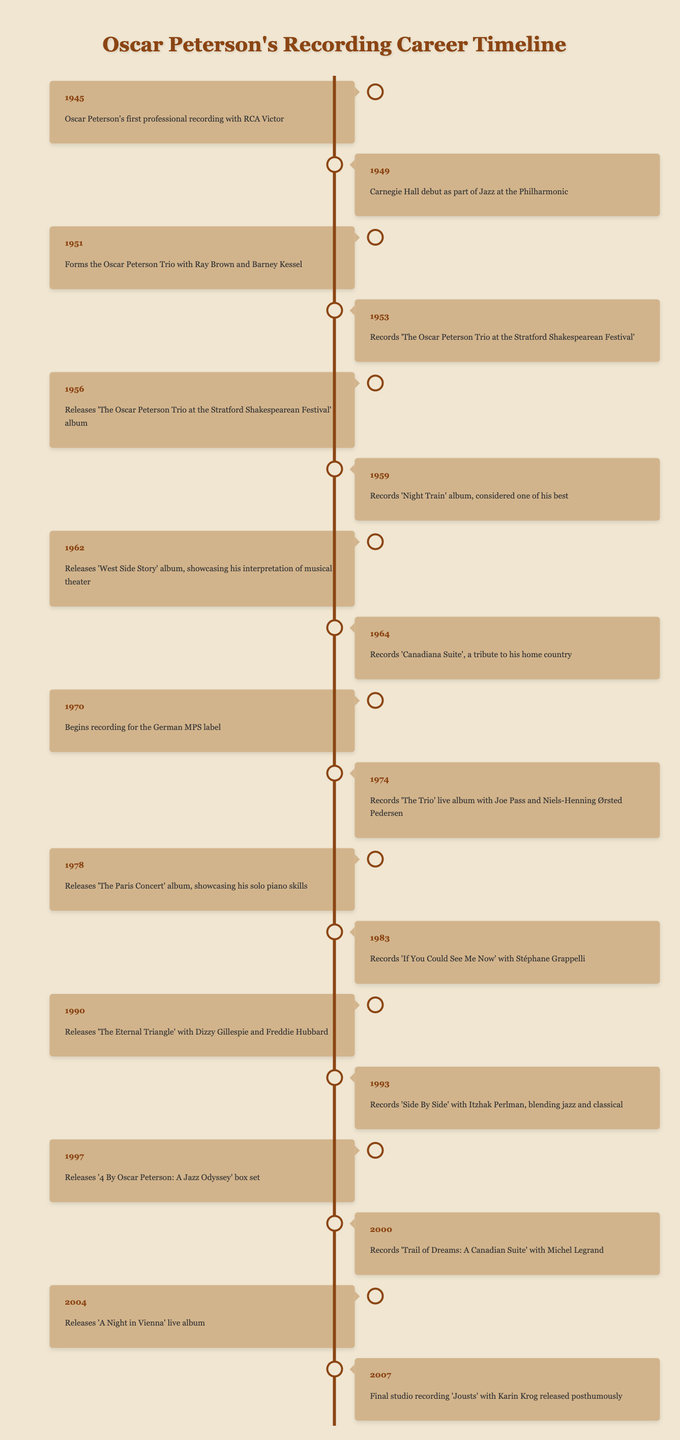What year did Oscar Peterson release 'Night Train'? The table shows that 'Night Train' was recorded in the year 1959.
Answer: 1959 What event took place in 1974? The 1974 entry in the table indicates that he recorded 'The Trio' live album with Joe Pass and Niels-Henning Ørsted Pedersen.
Answer: Records 'The Trio' live album with Joe Pass and Niels-Henning Ørsted Pedersen Did Oscar Peterson form the Oscar Peterson Trio before or after 1950? The table states he formed the Oscar Peterson Trio in 1951, which is after 1950.
Answer: After How many albums did Oscar Peterson release from 1950 to 1970? From 1951 to 1970, the table lists five albums: 'The Oscar Peterson Trio at the Stratford Shakespearean Festival' (1956), 'Night Train' (1959), 'West Side Story' (1962), 'Canadiana Suite' (1964), and 'Begins recording for the German MPS label' (1970). Thus, he released five albums in total.
Answer: 5 What is the first event listed in the timeline? The first event in the timeline is Oscar Peterson's first professional recording with RCA Victor, which occurred in 1945.
Answer: Oscar Peterson's first professional recording with RCA Victor Which albums showcase his solo piano skills? The table mentions 'The Paris Concert' released in 1978 as showcasing his solo piano skills.
Answer: 'The Paris Concert' How many years separate the recording of 'The Eternal Triangle' and '4 By Oscar Peterson: A Jazz Odyssey'? 'The Eternal Triangle' was released in 1990 and '4 By Oscar Peterson: A Jazz Odyssey' in 1997, making it a difference of 7 years (1997 - 1990).
Answer: 7 years Was there a significant gap between Peterson's recordings in the 1960s and those in the 1970s? The last recording in the 1960s was in 1970, and the first recording in the 1970s was also in 1970, so there was no gap.
Answer: No gap What was the last studio recording Oscar Peterson made? The last studio recording noted in the table is 'Jousts' with Karin Krog, released posthumously in 2007.
Answer: 'Jousts' with Karin Krog 